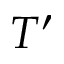<formula> <loc_0><loc_0><loc_500><loc_500>T ^ { \prime }</formula> 